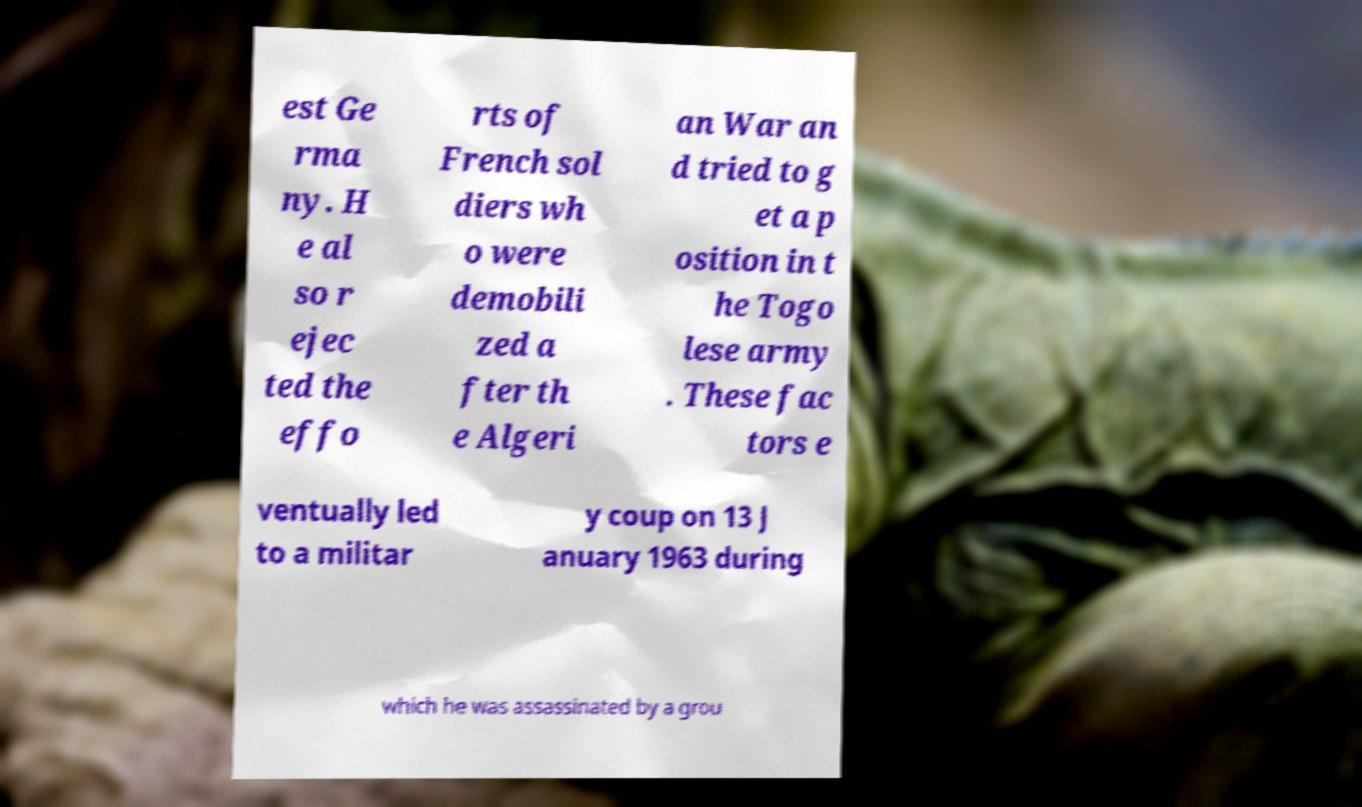There's text embedded in this image that I need extracted. Can you transcribe it verbatim? est Ge rma ny. H e al so r ejec ted the effo rts of French sol diers wh o were demobili zed a fter th e Algeri an War an d tried to g et a p osition in t he Togo lese army . These fac tors e ventually led to a militar y coup on 13 J anuary 1963 during which he was assassinated by a grou 